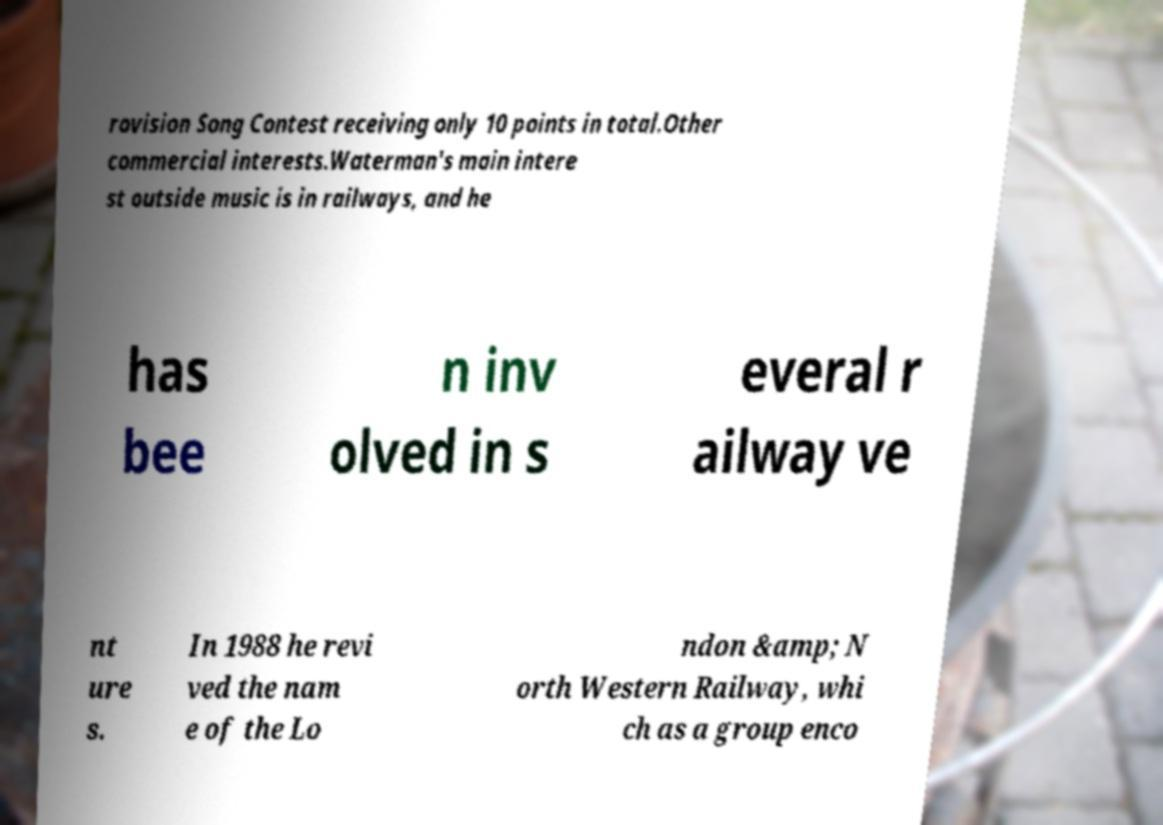There's text embedded in this image that I need extracted. Can you transcribe it verbatim? rovision Song Contest receiving only 10 points in total.Other commercial interests.Waterman's main intere st outside music is in railways, and he has bee n inv olved in s everal r ailway ve nt ure s. In 1988 he revi ved the nam e of the Lo ndon &amp; N orth Western Railway, whi ch as a group enco 